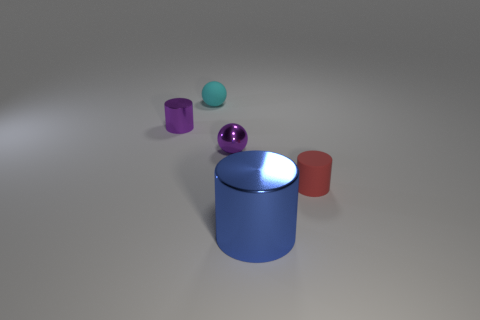Add 4 purple cylinders. How many objects exist? 9 Subtract all spheres. How many objects are left? 3 Add 5 small brown shiny cylinders. How many small brown shiny cylinders exist? 5 Subtract 0 yellow cylinders. How many objects are left? 5 Subtract all cylinders. Subtract all purple spheres. How many objects are left? 1 Add 4 tiny cyan matte objects. How many tiny cyan matte objects are left? 5 